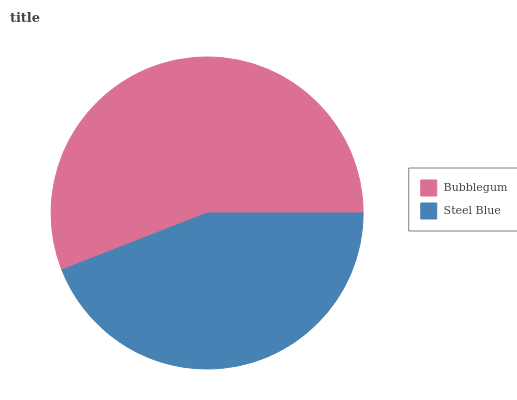Is Steel Blue the minimum?
Answer yes or no. Yes. Is Bubblegum the maximum?
Answer yes or no. Yes. Is Steel Blue the maximum?
Answer yes or no. No. Is Bubblegum greater than Steel Blue?
Answer yes or no. Yes. Is Steel Blue less than Bubblegum?
Answer yes or no. Yes. Is Steel Blue greater than Bubblegum?
Answer yes or no. No. Is Bubblegum less than Steel Blue?
Answer yes or no. No. Is Bubblegum the high median?
Answer yes or no. Yes. Is Steel Blue the low median?
Answer yes or no. Yes. Is Steel Blue the high median?
Answer yes or no. No. Is Bubblegum the low median?
Answer yes or no. No. 